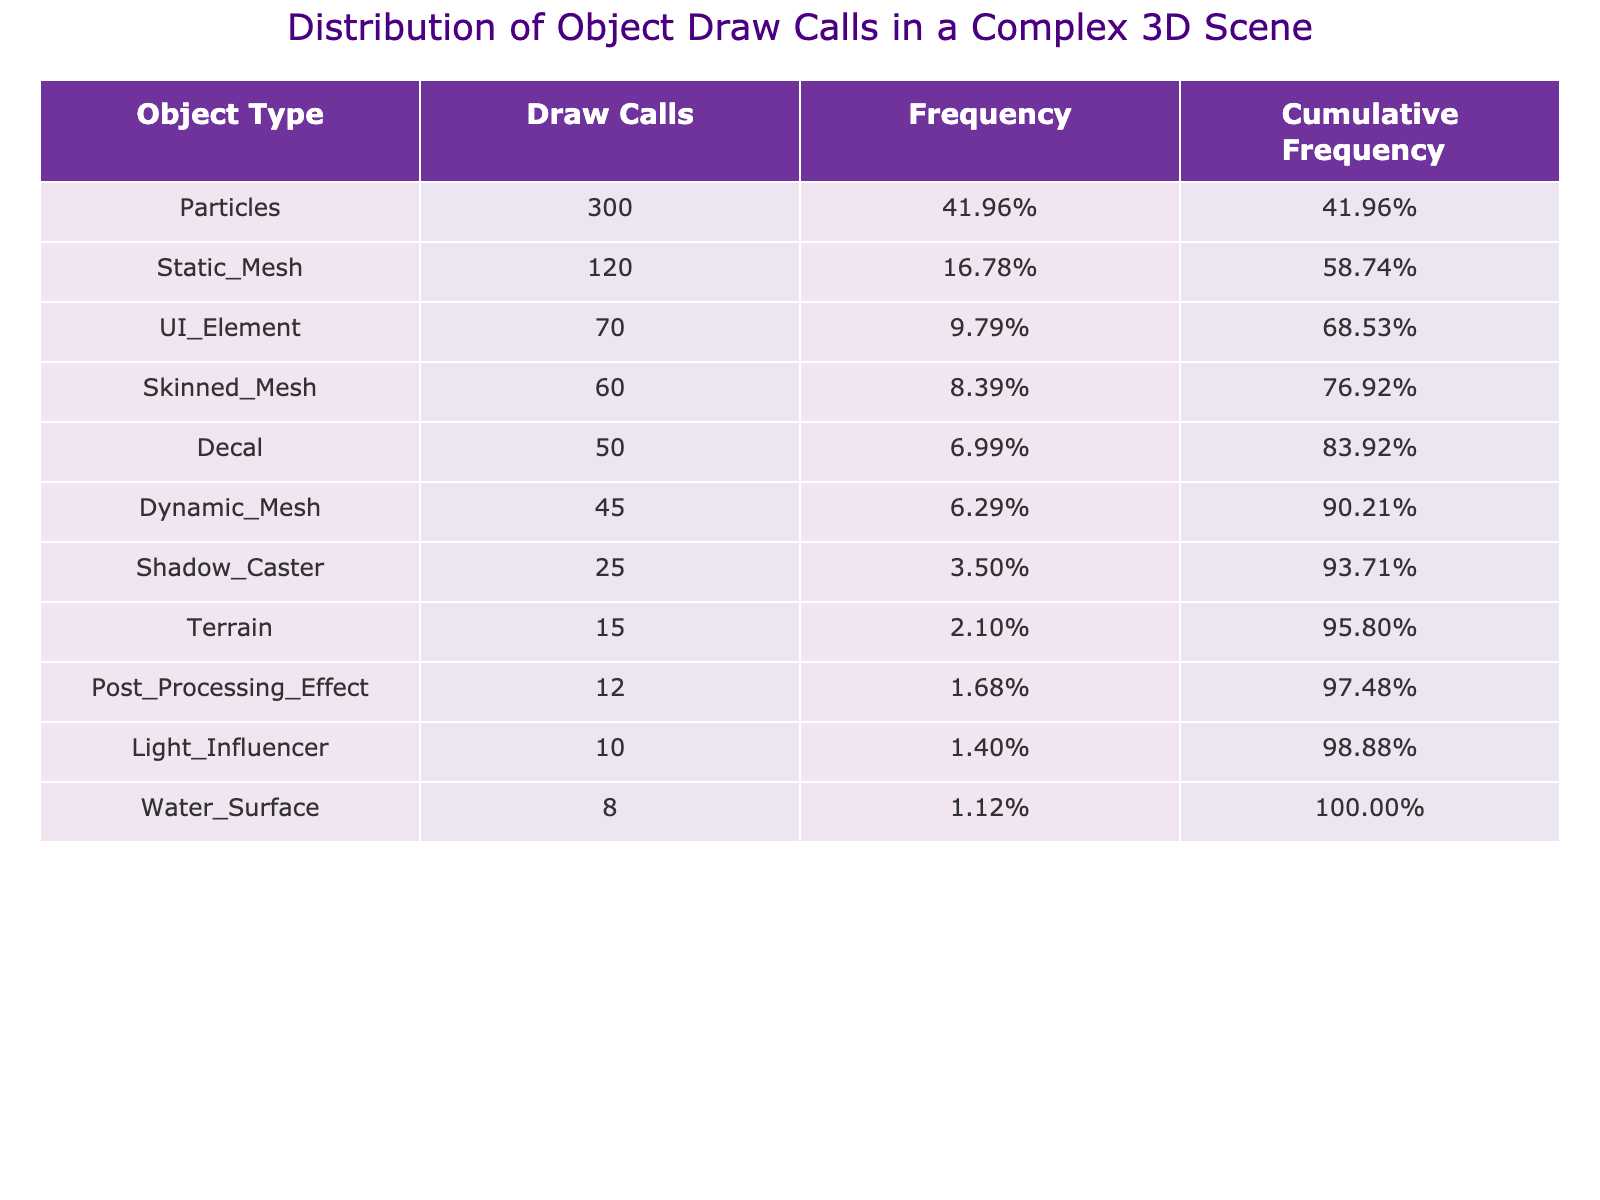What is the total number of draw calls for all object types? To find the total number of draw calls, we sum the values from the "Draw Calls" column: 120 + 45 + 300 + 60 + 70 + 10 + 25 + 15 + 50 + 8 + 12 = 600.
Answer: 600 Which object type has the highest number of draw calls? By looking at the "Draw Calls" column, the highest value is 300, which corresponds to the "Particles" object type.
Answer: Particles What percentage of draw calls do Static Meshes represent? The draw calls for Static Meshes are 120. To find the percentage, we calculate (120 / 600) * 100 = 20%.
Answer: 20% How many more draw calls does UI Element have compared to Light Influencer? UI Element has 70 draw calls and Light Influencer has 10. The difference is 70 - 10 = 60.
Answer: 60 Is it true that Terrain has more draw calls than Post Processing Effect? Terrain has 15 draw calls while Post Processing Effect has 12. Since 15 is greater than 12, the statement is true.
Answer: Yes What is the cumulative frequency for Dynamic Mesh objects? The cumulative frequency for Dynamic Mesh can be found by adding the frequencies of all object types up to Dynamic Mesh: Static Mesh (20%) + Dynamic Mesh (7.5%) = 27.5%.
Answer: 27.5% Which two object types combined have fewer draw calls than Particles alone? Particles have 300 draw calls. Adding the draw calls for Dynamic Mesh (45) and Skinned Mesh (60) gives us 45 + 60 = 105, which is less than 300.
Answer: Yes What is the median number of draw calls among all object types? To find the median, we first list the draw calls in ascending order: 8, 10, 12, 15, 25, 45, 50, 60, 70, 120, 300. There are 11 values, so the median is the 6th value: 45.
Answer: 45 How many object types have more draw calls than the average? The average draw calls are calculated as 600 (total) / 11 (types) = 54.5. The object types with more than 54.5 draw calls are Static Mesh, Particles, and Skinned Mesh. That’s a total of 3 object types.
Answer: 3 